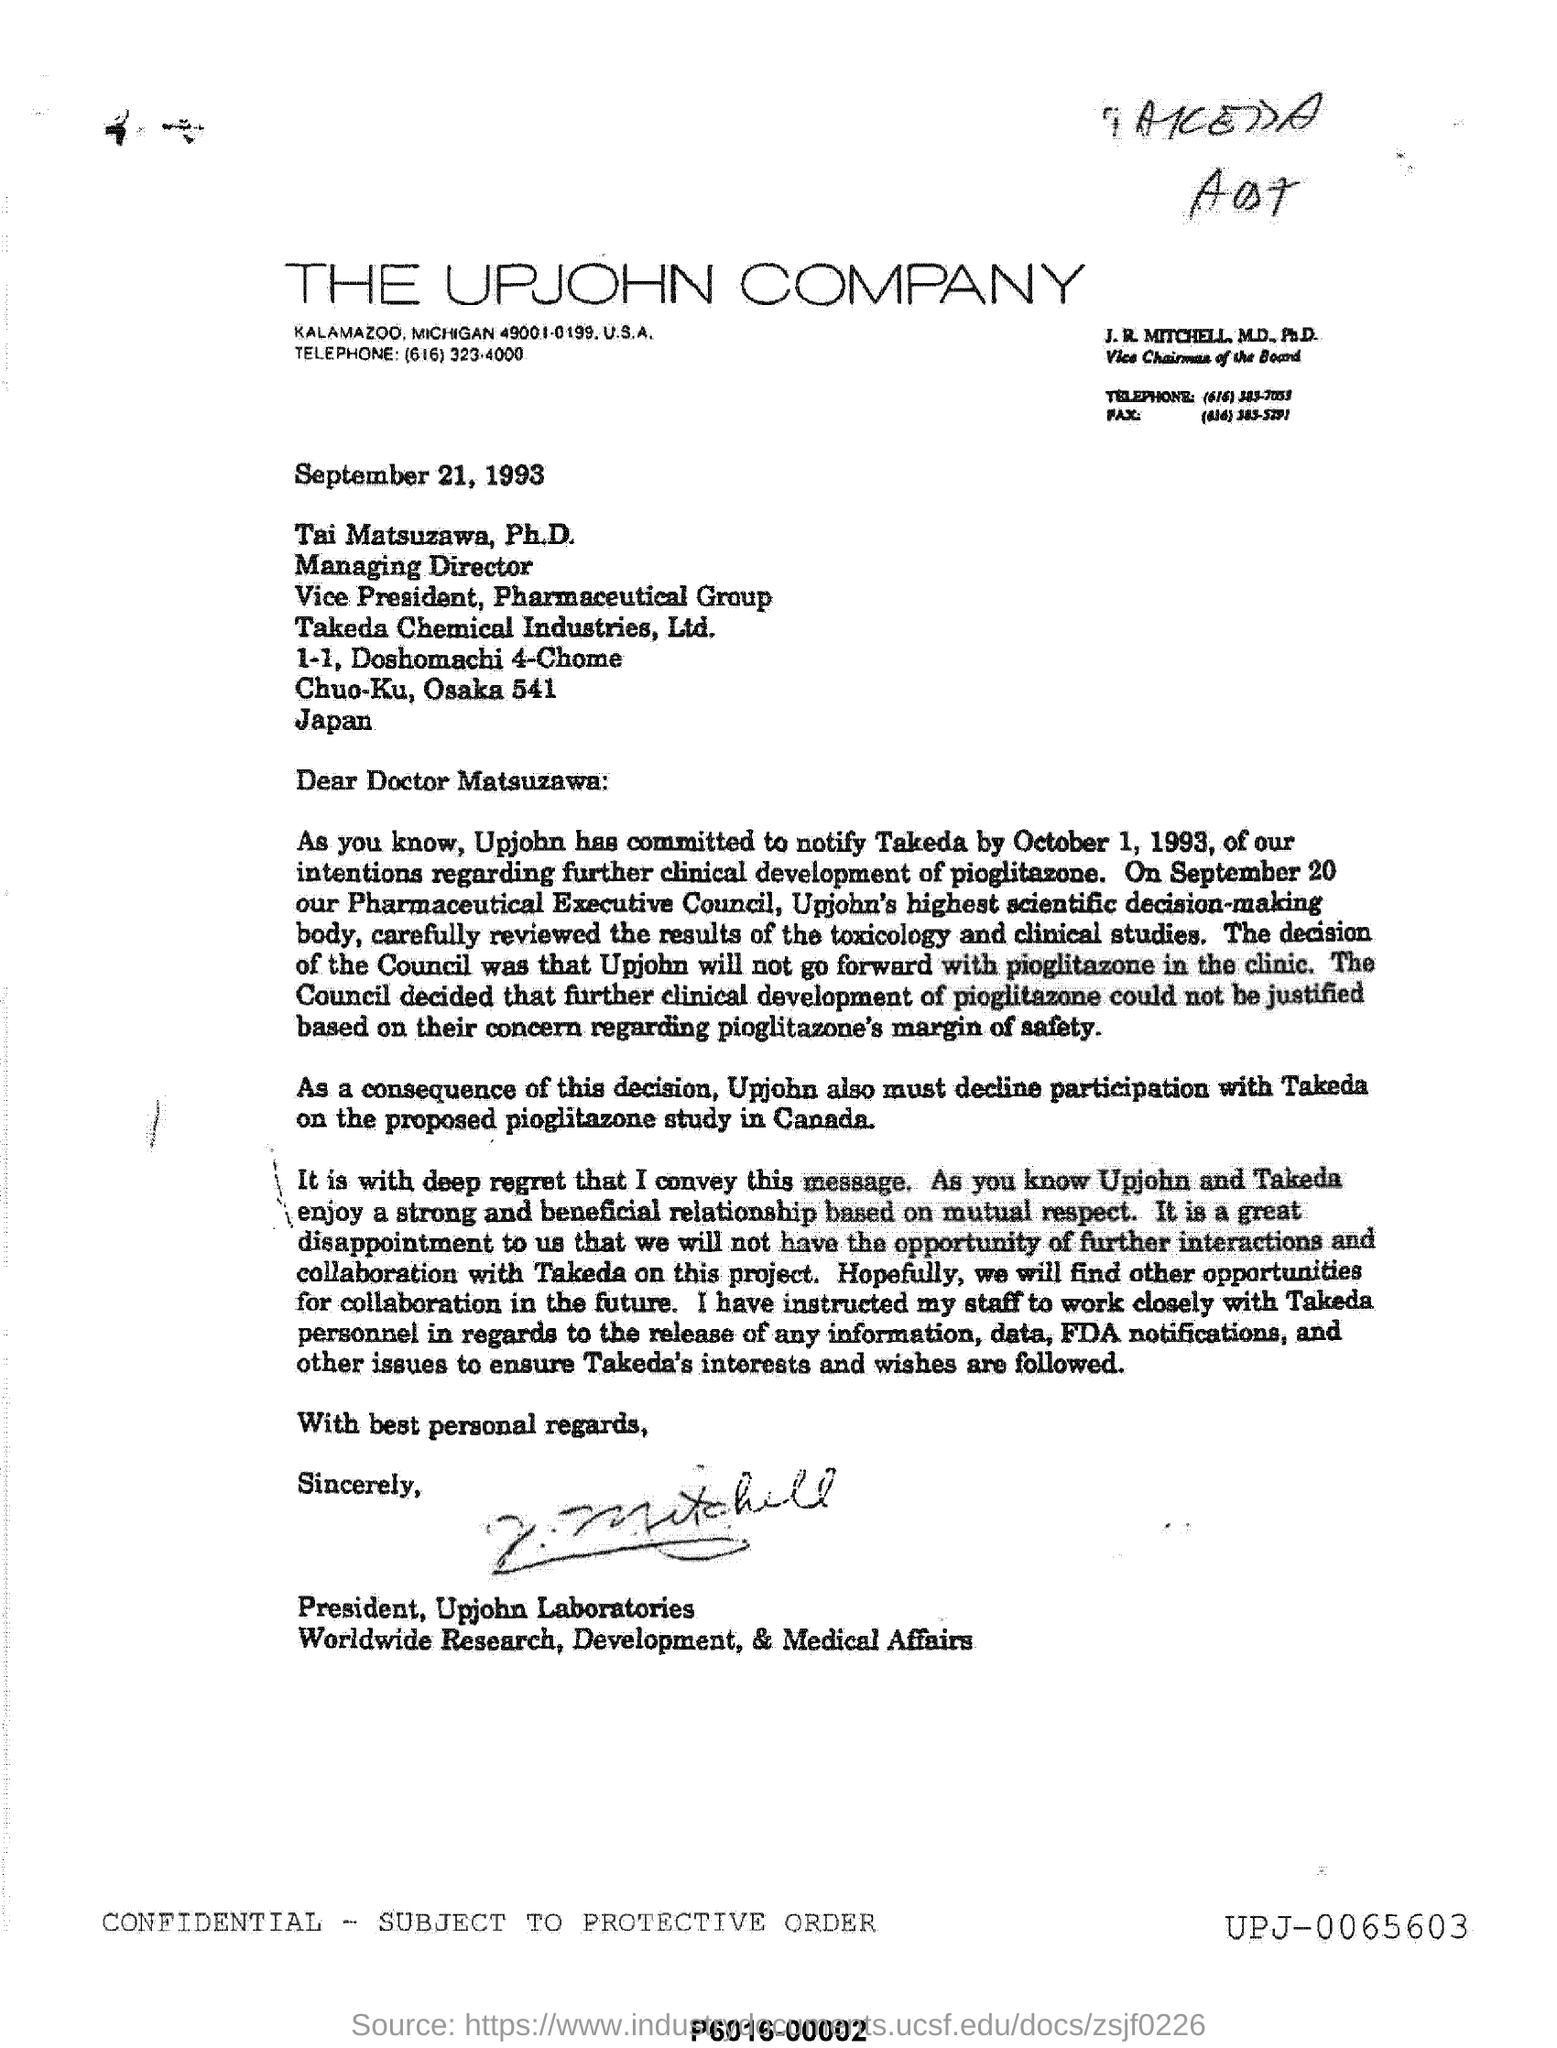What is the name of the company
Offer a terse response. THE UPJOHN COMPANY. What is the date and year mentioned ?
Your answer should be very brief. September 21, 1993. Which company is mentioned in the letterhead?
Provide a short and direct response. THE UPJOHN COMPANY. In which country the upjohn company is located ?
Give a very brief answer. U.S.A. 